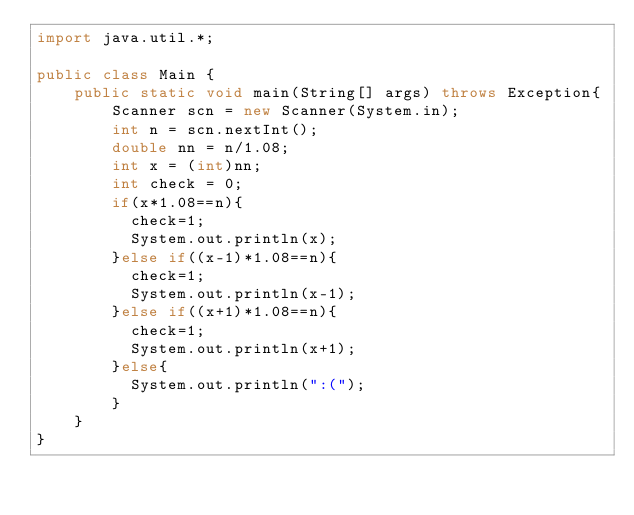Convert code to text. <code><loc_0><loc_0><loc_500><loc_500><_Java_>import java.util.*;

public class Main {
	public static void main(String[] args) throws Exception{
		Scanner scn = new Scanner(System.in);
		int n = scn.nextInt();
		double nn = n/1.08;
      	int x = (int)nn;
      	int check = 0;
      	if(x*1.08==n){
          check=1;
          System.out.println(x);
        }else if((x-1)*1.08==n){
          check=1;
          System.out.println(x-1);
        }else if((x+1)*1.08==n){
          check=1;
          System.out.println(x+1);
        }else{
          System.out.println(":(");
        }
	}
}
</code> 